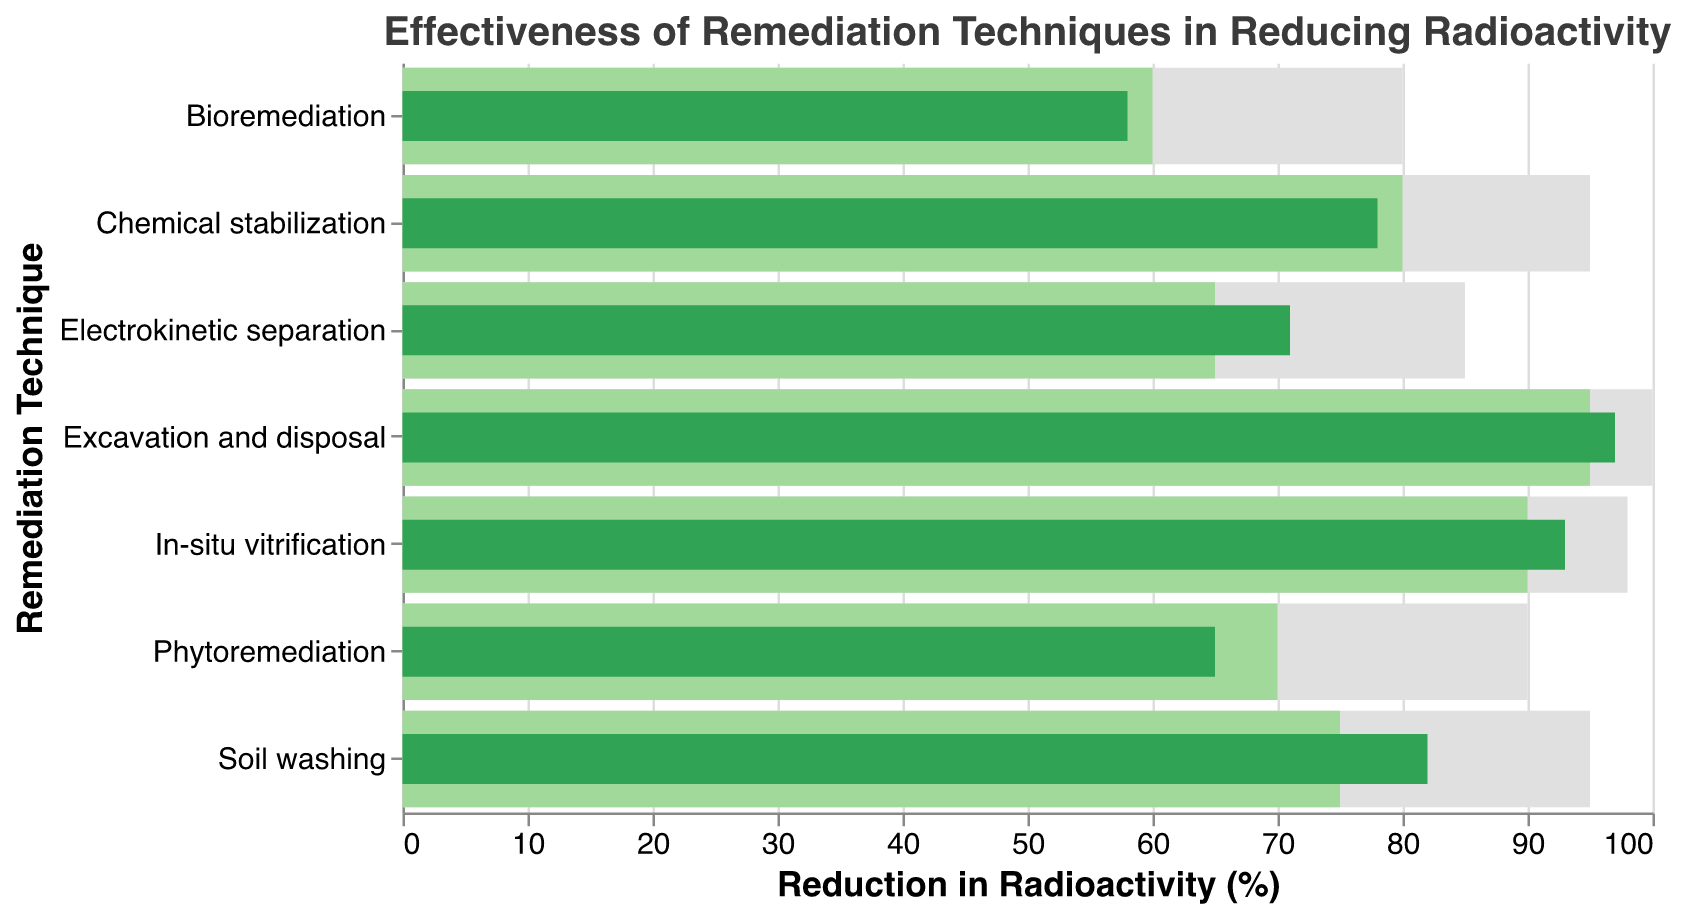What's the title of the chart? The title is displayed at the top of the chart, it reads "Effectiveness of Remediation Techniques in Reducing Radioactivity".
Answer: Effectiveness of Remediation Techniques in Reducing Radioactivity Which remediation technique has the highest actual reduction? The actual reduction of each technique is represented by the green bar, and "Excavation and disposal" has the highest actual reduction at 97%.
Answer: Excavation and disposal What is the maximum possible reduction for "Soil washing"? The maximum reduction for "Soil washing" can be seen from the top gray bar, and it reaches up to 95%.
Answer: 95% How many remediation techniques have an actual reduction higher than their target reduction? By closely examining the green bars (actual reduction) in relation to the lighter green bars (target reduction), we see that "Soil washing", "In-situ vitrification", "Electrokinetic separation", and "Excavation and disposal" all have actual reductions higher than their target reductions.
Answer: 4 Which techniques have actual reductions below their target reductions? Comparing the green bars (actual reduction) to the lighter green bars (target reduction), the techniques "Phytoremediation", "Bioremediation", and "Chemical stabilization" show actual reductions below their target reductions.
Answer: Phytoremediation, Bioremediation, Chemical stabilization How does the actual reduction of "Bioremediation" compare to its target reduction? "Bioremediation" has an actual reduction displayed by the green bar at 58%, while its target reduction, indicated by the lighter green bar, is at 60%. The actual reduction is 2% less than the target reduction.
Answer: 2% less What is the difference between the actual and maximum reduction for "In-situ vitrification"? The actual reduction for "In-situ vitrification" is 93% as shown by the green bar, and the maximum reduction is 98% as shown by the gray bar. The difference is 98% - 93% = 5%.
Answer: 5% Which remediation technique has the smallest gap between its actual and maximum reduction? By comparing the lengths of the green and gray bars for each technique, it is evident that "Excavation and disposal" has the smallest gap, since its actual reduction is 97% and maximum reduction is 100%, resulting in a gap of 3%.
Answer: Excavation and disposal How many techniques have a maximum reduction of 95% or more? The gray bars representing maximum reduction show that "Soil washing", "In-situ vitrification", "Chemical stabilization", and "Excavation and disposal" all have a maximum reduction of 95% or more.
Answer: 4 Which technique had an actual reduction furthest below its maximum reduction and by how much? Comparing the green and gray bars, "Phytoremediation" has an actual reduction of 65% and a maximum reduction of 90%, indicating the largest gap of 90% - 65% = 25%.
Answer: Phytoremediation, 25% 